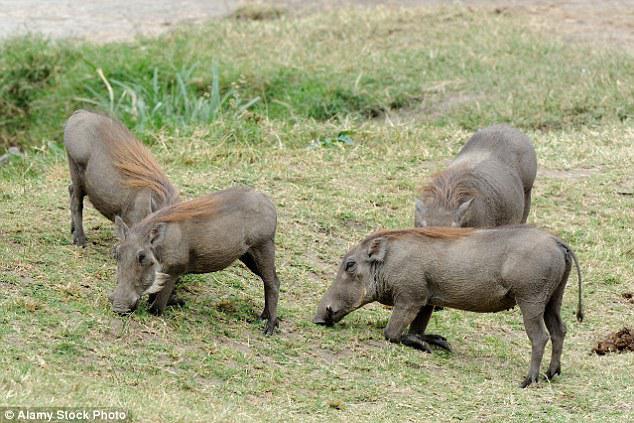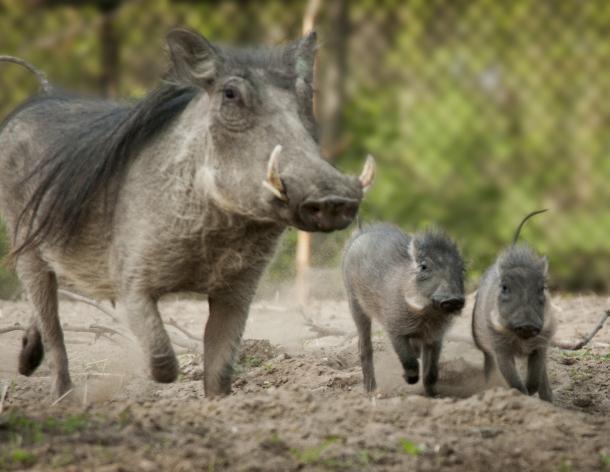The first image is the image on the left, the second image is the image on the right. Assess this claim about the two images: "Right image contains one forward facing adult boar and multiple baby boars.". Correct or not? Answer yes or no. Yes. The first image is the image on the left, the second image is the image on the right. Analyze the images presented: Is the assertion "One of the images contains exactly two baby boars." valid? Answer yes or no. Yes. 